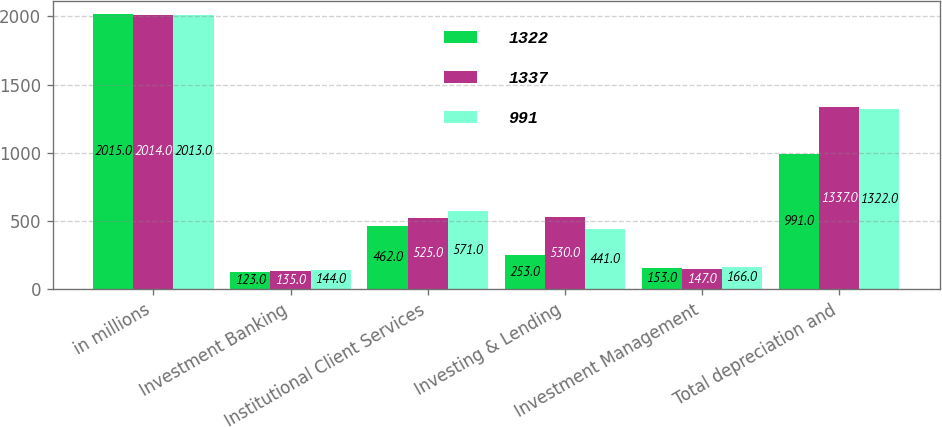Convert chart. <chart><loc_0><loc_0><loc_500><loc_500><stacked_bar_chart><ecel><fcel>in millions<fcel>Investment Banking<fcel>Institutional Client Services<fcel>Investing & Lending<fcel>Investment Management<fcel>Total depreciation and<nl><fcel>1322<fcel>2015<fcel>123<fcel>462<fcel>253<fcel>153<fcel>991<nl><fcel>1337<fcel>2014<fcel>135<fcel>525<fcel>530<fcel>147<fcel>1337<nl><fcel>991<fcel>2013<fcel>144<fcel>571<fcel>441<fcel>166<fcel>1322<nl></chart> 